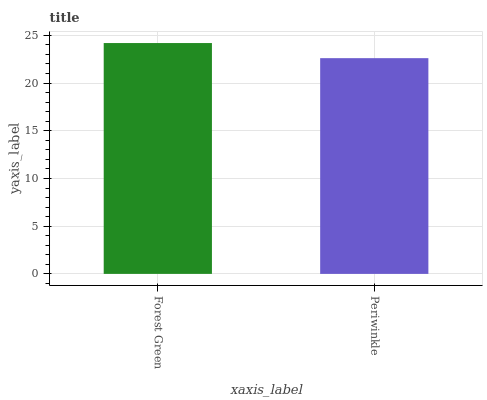Is Periwinkle the minimum?
Answer yes or no. Yes. Is Forest Green the maximum?
Answer yes or no. Yes. Is Periwinkle the maximum?
Answer yes or no. No. Is Forest Green greater than Periwinkle?
Answer yes or no. Yes. Is Periwinkle less than Forest Green?
Answer yes or no. Yes. Is Periwinkle greater than Forest Green?
Answer yes or no. No. Is Forest Green less than Periwinkle?
Answer yes or no. No. Is Forest Green the high median?
Answer yes or no. Yes. Is Periwinkle the low median?
Answer yes or no. Yes. Is Periwinkle the high median?
Answer yes or no. No. Is Forest Green the low median?
Answer yes or no. No. 